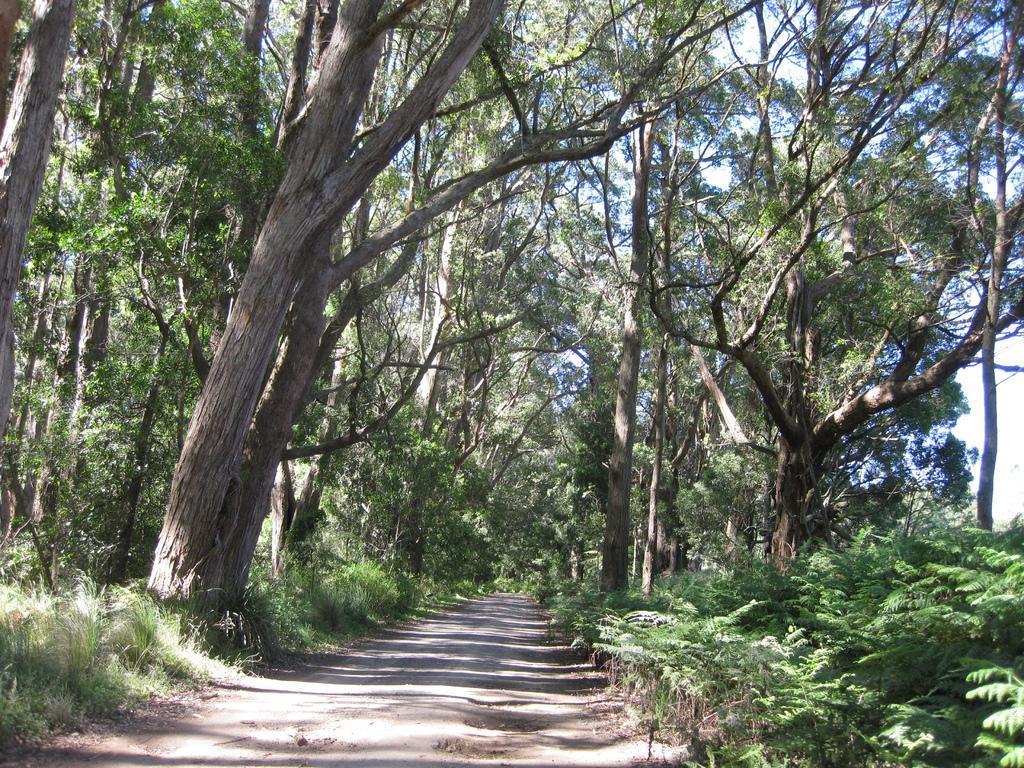Please provide a concise description of this image. This is grass. There are plants and trees. In the background there is sky. 